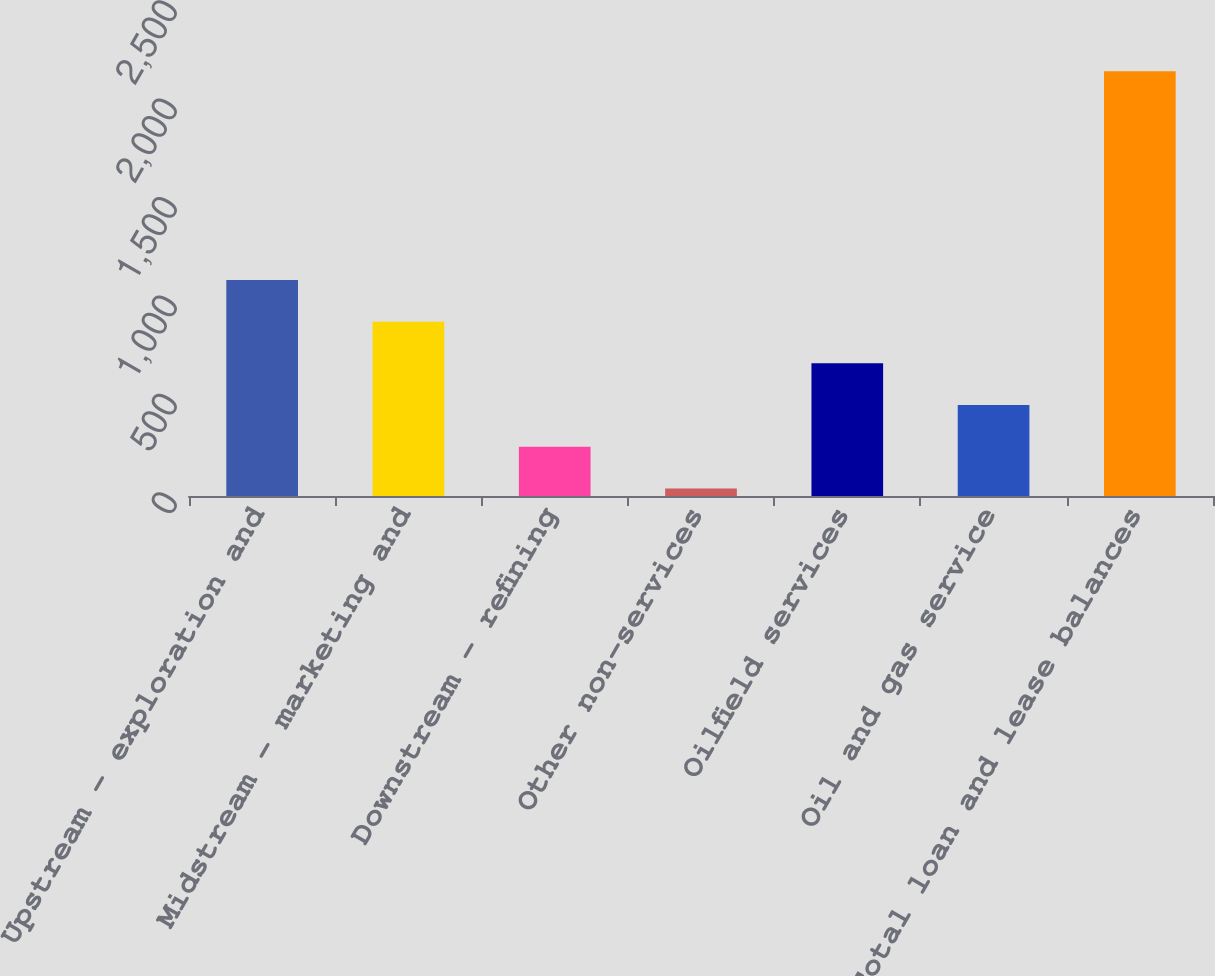Convert chart to OTSL. <chart><loc_0><loc_0><loc_500><loc_500><bar_chart><fcel>Upstream - exploration and<fcel>Midstream - marketing and<fcel>Downstream - refining<fcel>Other non-services<fcel>Oilfield services<fcel>Oil and gas service<fcel>Total loan and lease balances<nl><fcel>1098<fcel>886<fcel>250<fcel>38<fcel>674<fcel>462<fcel>2158<nl></chart> 